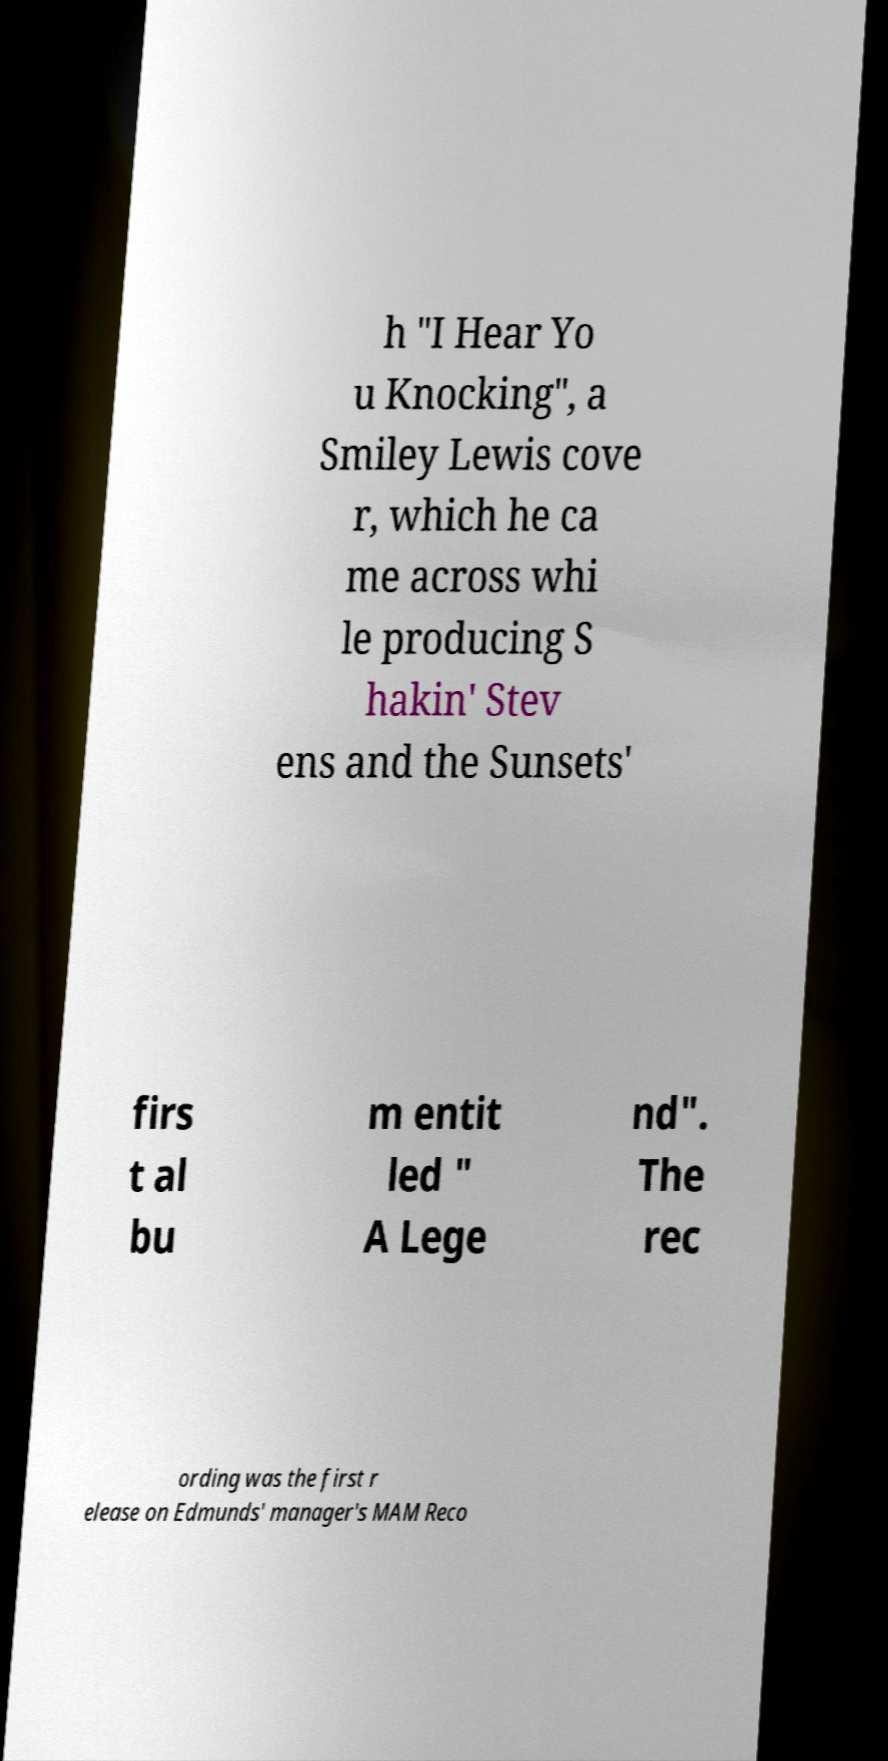Can you read and provide the text displayed in the image?This photo seems to have some interesting text. Can you extract and type it out for me? h "I Hear Yo u Knocking", a Smiley Lewis cove r, which he ca me across whi le producing S hakin' Stev ens and the Sunsets' firs t al bu m entit led " A Lege nd". The rec ording was the first r elease on Edmunds' manager's MAM Reco 